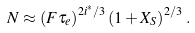Convert formula to latex. <formula><loc_0><loc_0><loc_500><loc_500>N \approx \left ( F \tau _ { e } \right ) ^ { 2 i ^ { * } / 3 } \left ( 1 + X _ { S } \right ) ^ { 2 / 3 } \, .</formula> 